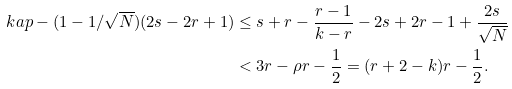<formula> <loc_0><loc_0><loc_500><loc_500>\ k a p - ( 1 - 1 / \sqrt { N } ) ( 2 s - 2 r + 1 ) & \leq s + r - \frac { r - 1 } { k - r } - 2 s + 2 r - 1 + \frac { 2 s } { \sqrt { N } } \\ & < 3 r - \rho r - \frac { 1 } { 2 } = ( r + 2 - k ) r - \frac { 1 } { 2 } .</formula> 